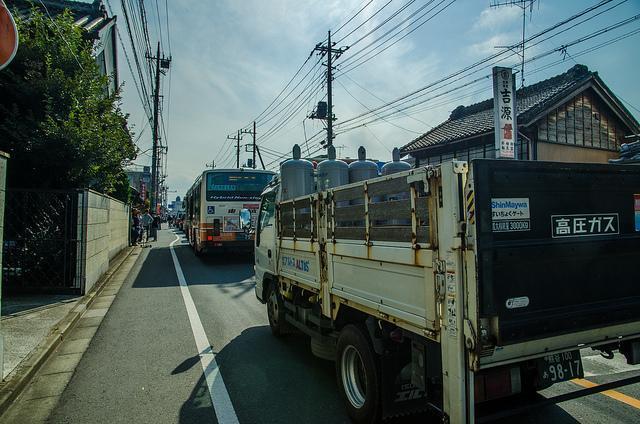Verify the accuracy of this image caption: "The truck is at the back of the bus.".
Answer yes or no. Yes. 